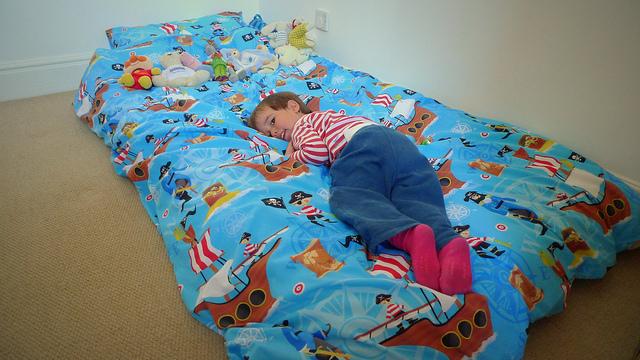Are there toys on the bed?
Quick response, please. Yes. Is the boy asleep?
Be succinct. No. Is the boy smiling?
Concise answer only. Yes. 